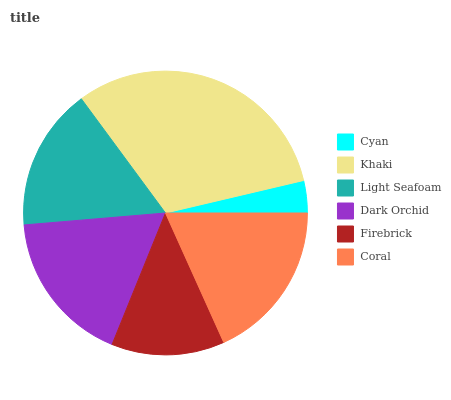Is Cyan the minimum?
Answer yes or no. Yes. Is Khaki the maximum?
Answer yes or no. Yes. Is Light Seafoam the minimum?
Answer yes or no. No. Is Light Seafoam the maximum?
Answer yes or no. No. Is Khaki greater than Light Seafoam?
Answer yes or no. Yes. Is Light Seafoam less than Khaki?
Answer yes or no. Yes. Is Light Seafoam greater than Khaki?
Answer yes or no. No. Is Khaki less than Light Seafoam?
Answer yes or no. No. Is Dark Orchid the high median?
Answer yes or no. Yes. Is Light Seafoam the low median?
Answer yes or no. Yes. Is Light Seafoam the high median?
Answer yes or no. No. Is Firebrick the low median?
Answer yes or no. No. 